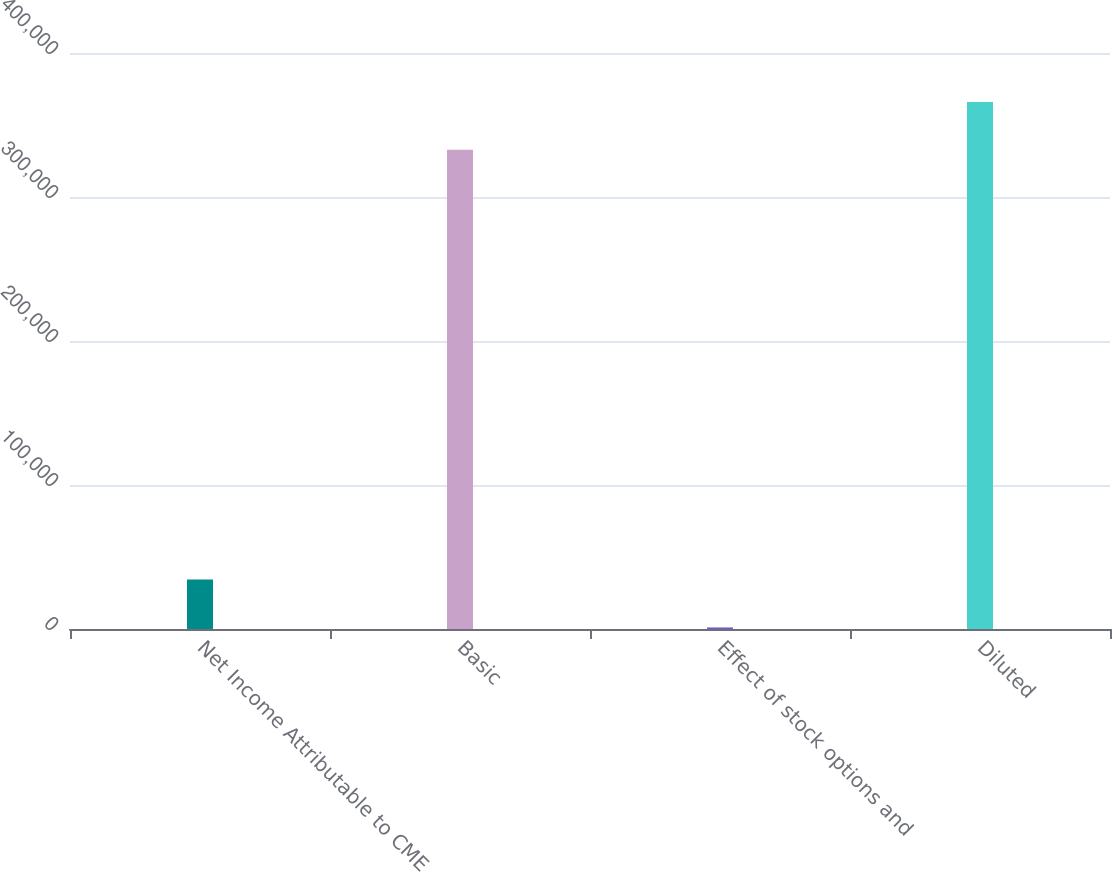<chart> <loc_0><loc_0><loc_500><loc_500><bar_chart><fcel>Net Income Attributable to CME<fcel>Basic<fcel>Effect of stock options and<fcel>Diluted<nl><fcel>34347.7<fcel>332737<fcel>1074<fcel>366011<nl></chart> 